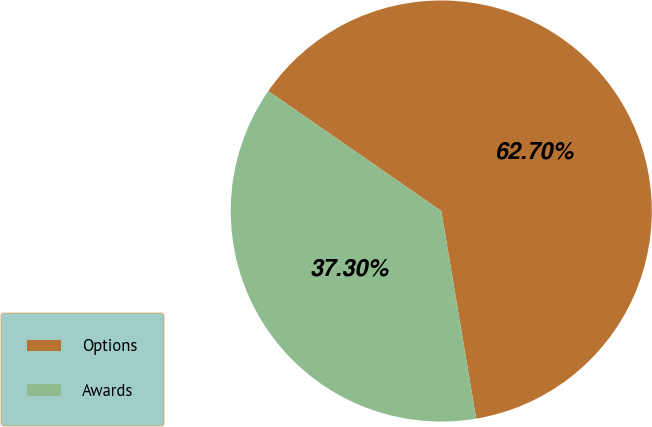Convert chart. <chart><loc_0><loc_0><loc_500><loc_500><pie_chart><fcel>Options<fcel>Awards<nl><fcel>62.7%<fcel>37.3%<nl></chart> 